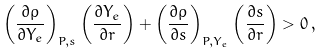Convert formula to latex. <formula><loc_0><loc_0><loc_500><loc_500>\left ( \frac { \partial \rho } { \partial Y _ { e } } \right ) _ { P , s } \left ( \frac { \partial Y _ { e } } { \partial r } \right ) + \left ( \frac { \partial \rho } { \partial s } \right ) _ { P , Y _ { e } } \left ( \frac { \partial s } { \partial r } \right ) > 0 \, ,</formula> 